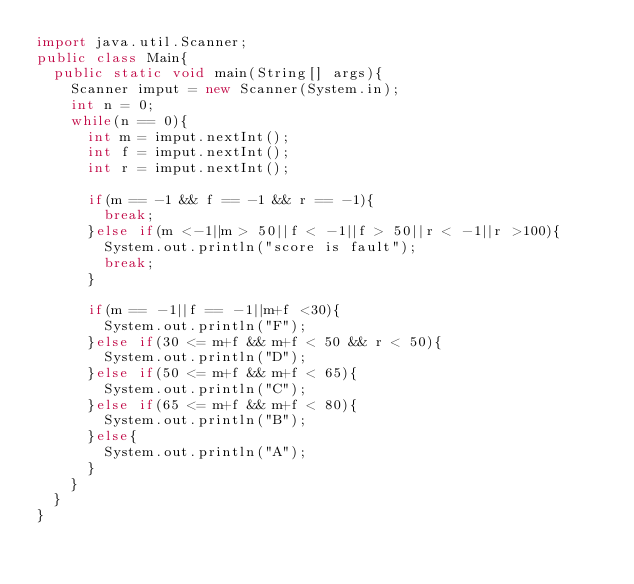<code> <loc_0><loc_0><loc_500><loc_500><_Java_>import java.util.Scanner;
public class Main{
	public static void main(String[] args){
		Scanner imput = new Scanner(System.in);
		int n = 0;
		while(n == 0){
			int m = imput.nextInt();
			int f = imput.nextInt();
			int r = imput.nextInt();
			
			if(m == -1 && f == -1 && r == -1){
				break;
			}else if(m <-1||m > 50||f < -1||f > 50||r < -1||r >100){
				System.out.println("score is fault");
				break;
			}

			if(m == -1||f == -1||m+f <30){
				System.out.println("F");
			}else if(30 <= m+f && m+f < 50 && r < 50){
				System.out.println("D");
			}else if(50 <= m+f && m+f < 65){
				System.out.println("C");
			}else if(65 <= m+f && m+f < 80){
				System.out.println("B");
			}else{
				System.out.println("A");
			}
		}
	}
}</code> 